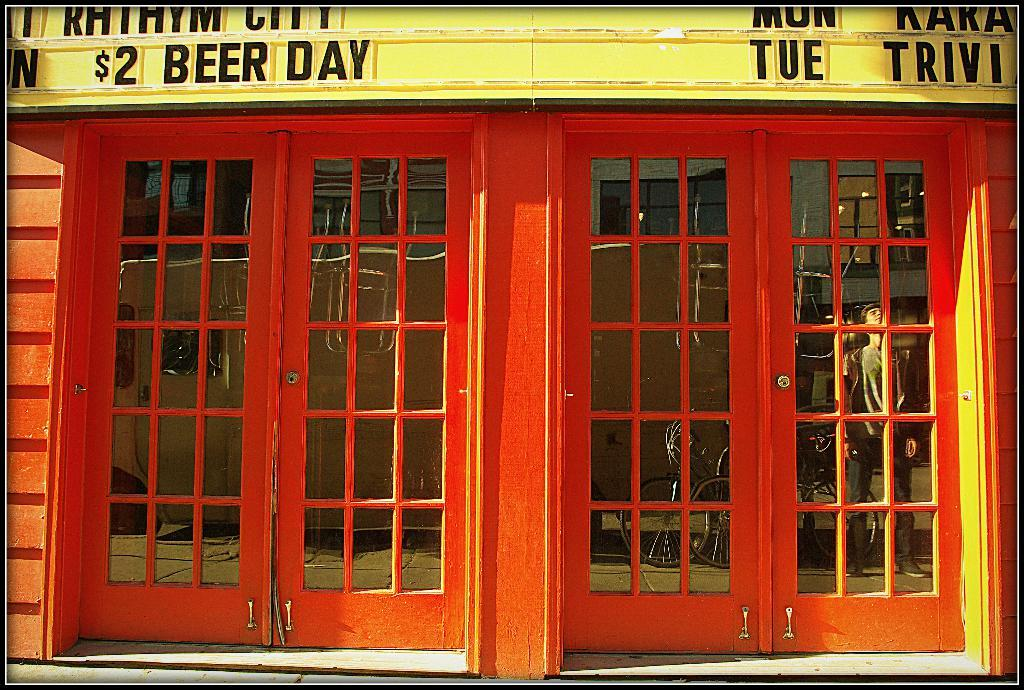What type of structure is present in the image? There is a building in the image. What colors are used on the building? The building has red and yellow colors. Can you describe any reflections visible on the glass door? There is a reflection of a person and a bicycle on the glass door. Is there a flame coming out of the building in the image? No, there is no flame present in the image. Can you describe the haircut of the person reflected on the glass door? There is no information about the person's haircut in the image, as we can only see their reflection. 